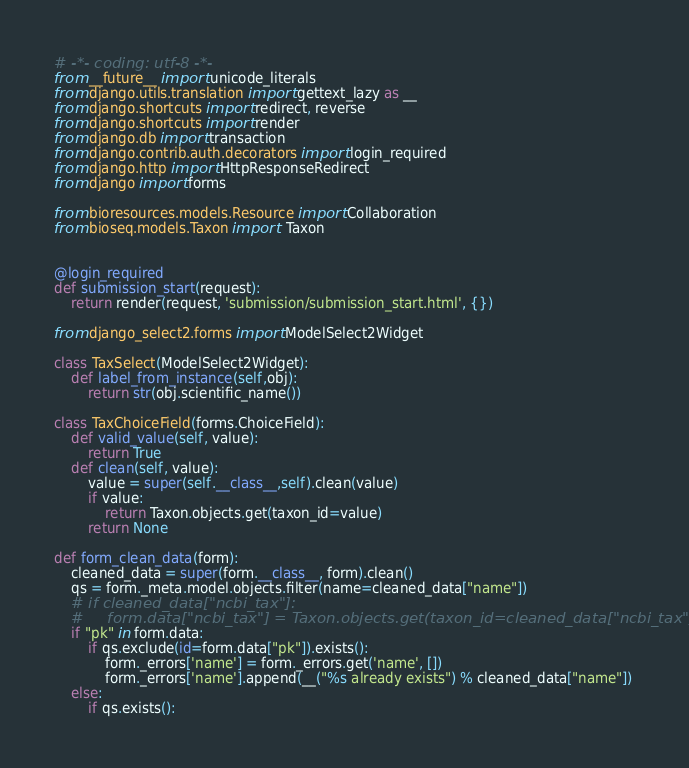Convert code to text. <code><loc_0><loc_0><loc_500><loc_500><_Python_># -*- coding: utf-8 -*-
from __future__ import unicode_literals
from django.utils.translation import gettext_lazy as __
from django.shortcuts import redirect, reverse
from django.shortcuts import render
from django.db import transaction
from django.contrib.auth.decorators import login_required
from django.http import HttpResponseRedirect
from django import forms

from bioresources.models.Resource import Collaboration
from bioseq.models.Taxon import  Taxon


@login_required
def submission_start(request):
    return render(request, 'submission/submission_start.html', {})

from django_select2.forms import ModelSelect2Widget

class TaxSelect(ModelSelect2Widget):
    def label_from_instance(self,obj):
        return str(obj.scientific_name())

class TaxChoiceField(forms.ChoiceField):
    def valid_value(self, value):
        return True
    def clean(self, value):
        value = super(self.__class__,self).clean(value)
        if value:
            return Taxon.objects.get(taxon_id=value)
        return None

def form_clean_data(form):
    cleaned_data = super(form.__class__, form).clean()
    qs = form._meta.model.objects.filter(name=cleaned_data["name"])
    # if cleaned_data["ncbi_tax"]:
    #     form.data["ncbi_tax"] = Taxon.objects.get(taxon_id=cleaned_data["ncbi_tax"])
    if "pk" in form.data:
        if qs.exclude(id=form.data["pk"]).exists():
            form._errors['name'] = form._errors.get('name', [])
            form._errors['name'].append(__("%s already exists") % cleaned_data["name"])
    else:
        if qs.exists():</code> 